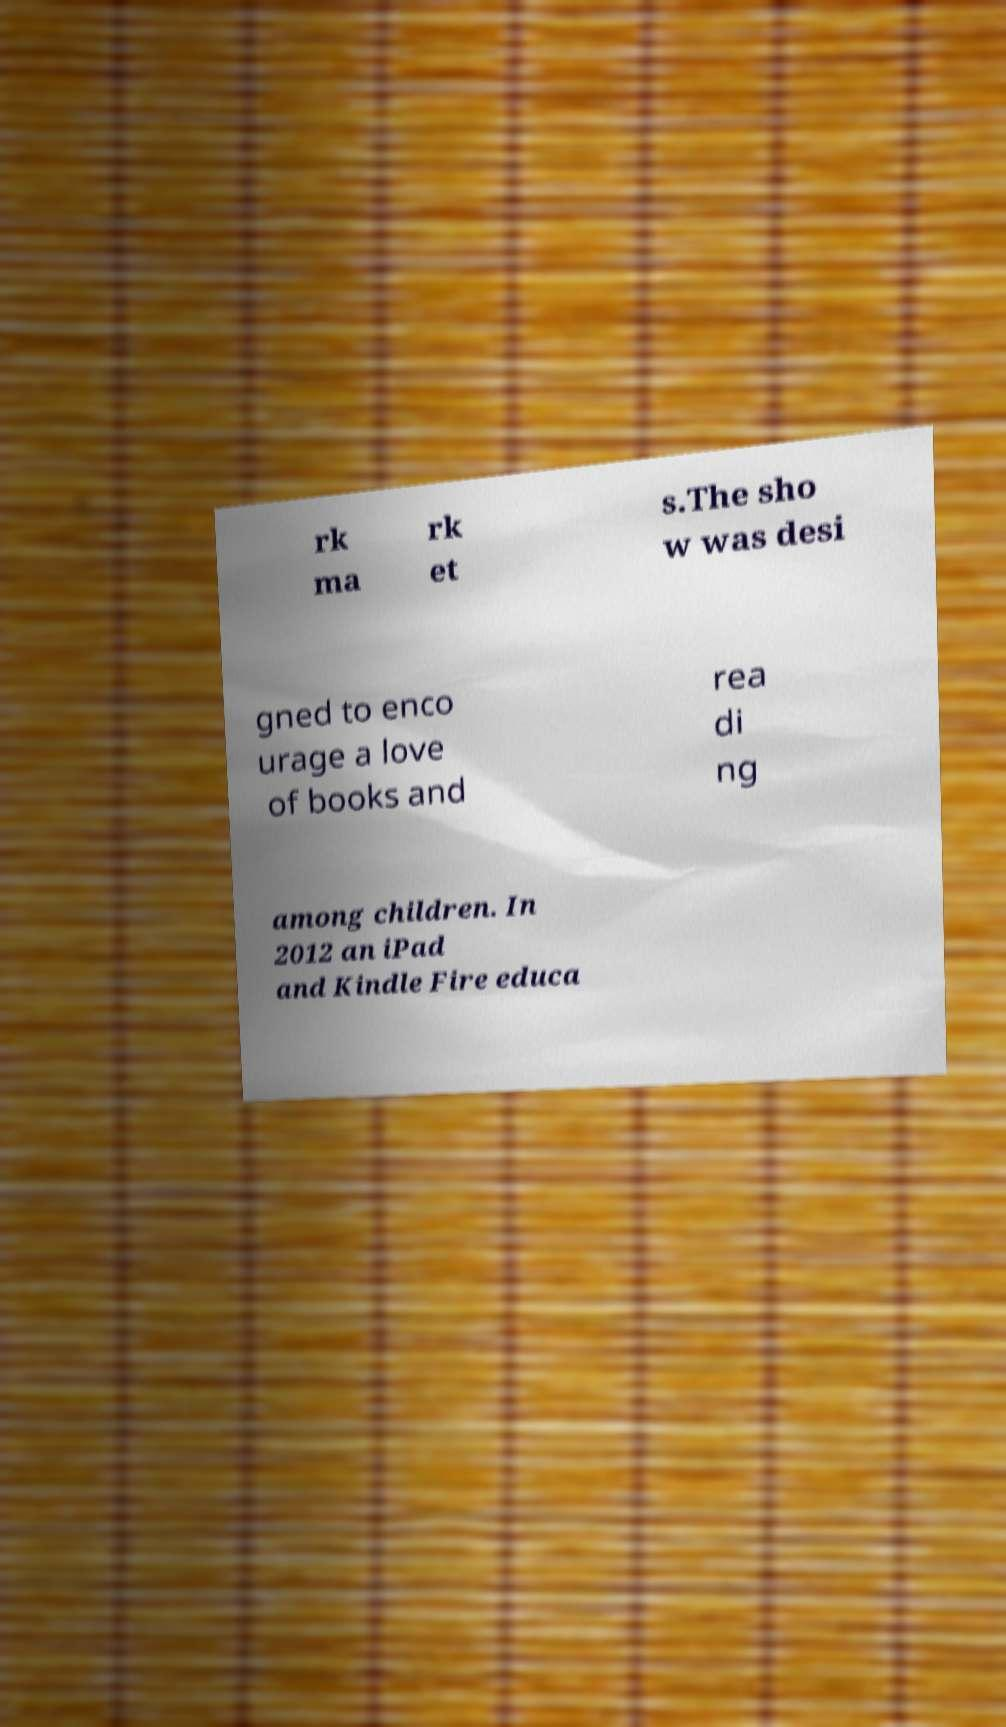For documentation purposes, I need the text within this image transcribed. Could you provide that? rk ma rk et s.The sho w was desi gned to enco urage a love of books and rea di ng among children. In 2012 an iPad and Kindle Fire educa 